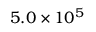Convert formula to latex. <formula><loc_0><loc_0><loc_500><loc_500>5 . 0 \times 1 0 ^ { 5 }</formula> 